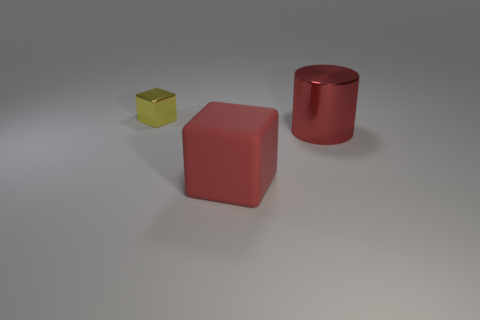Does the metallic cylinder have the same color as the rubber object?
Provide a succinct answer. Yes. There is another object that is the same color as the big shiny object; what is its material?
Keep it short and to the point. Rubber. Are there any other things that have the same size as the yellow metal cube?
Give a very brief answer. No. What number of objects are blocks behind the large red matte block or objects that are to the right of the small yellow metal cube?
Your answer should be compact. 3. There is a object that is behind the big rubber block and on the right side of the tiny yellow metal cube; what material is it?
Provide a short and direct response. Metal. What is the size of the block that is left of the big object that is in front of the red thing that is behind the large cube?
Your answer should be very brief. Small. Are there more tiny purple matte balls than rubber objects?
Your answer should be compact. No. Do the thing in front of the big red cylinder and the tiny yellow block have the same material?
Your answer should be compact. No. Is the number of large red things less than the number of big matte objects?
Your response must be concise. No. Is there a big cylinder to the left of the object behind the metallic object that is in front of the tiny shiny cube?
Your response must be concise. No. 